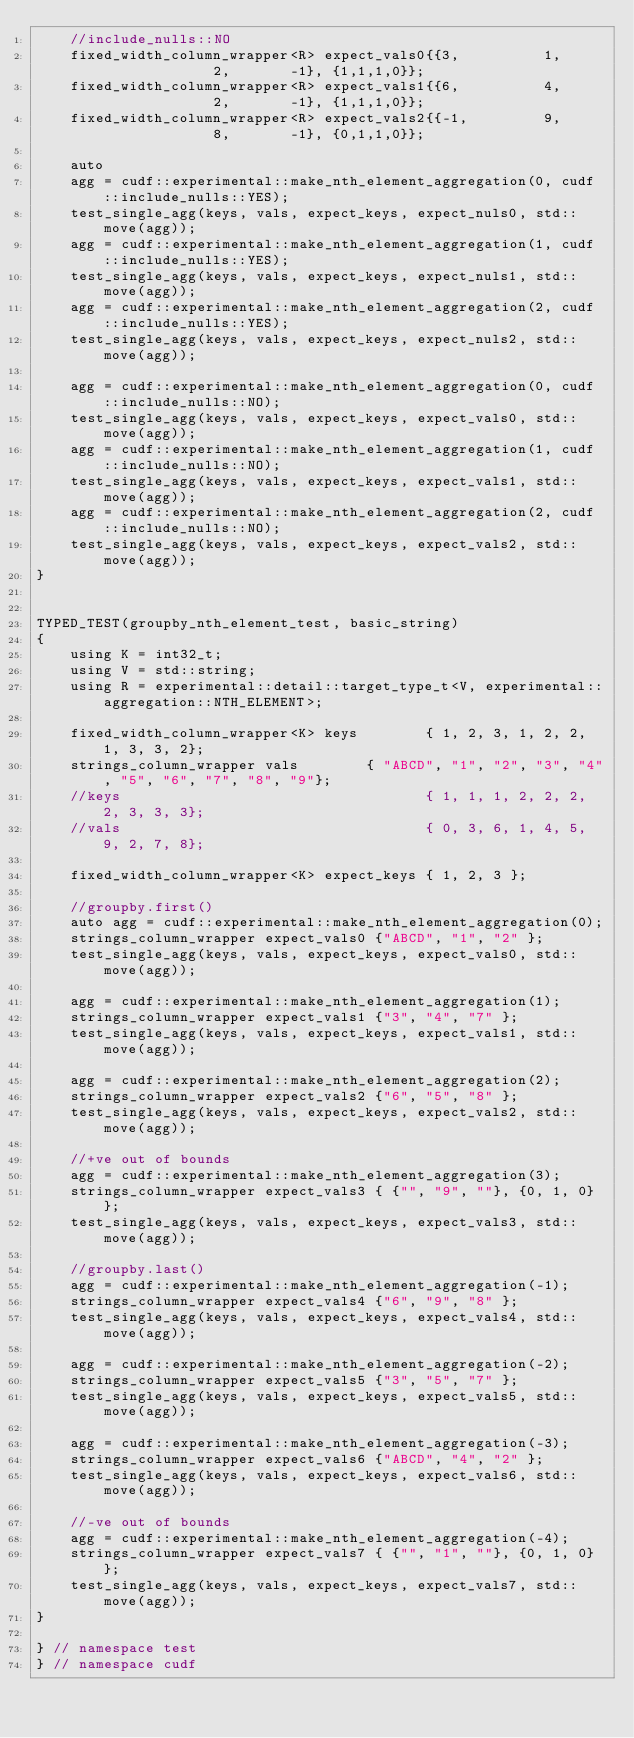Convert code to text. <code><loc_0><loc_0><loc_500><loc_500><_Cuda_>    //include_nulls::NO
    fixed_width_column_wrapper<R> expect_vals0{{3,          1,              2,       -1}, {1,1,1,0}};
    fixed_width_column_wrapper<R> expect_vals1{{6,          4,              2,       -1}, {1,1,1,0}};
    fixed_width_column_wrapper<R> expect_vals2{{-1,         9,              8,       -1}, {0,1,1,0}};

    auto 
    agg = cudf::experimental::make_nth_element_aggregation(0, cudf::include_nulls::YES);
    test_single_agg(keys, vals, expect_keys, expect_nuls0, std::move(agg));
    agg = cudf::experimental::make_nth_element_aggregation(1, cudf::include_nulls::YES);
    test_single_agg(keys, vals, expect_keys, expect_nuls1, std::move(agg));
    agg = cudf::experimental::make_nth_element_aggregation(2, cudf::include_nulls::YES);
    test_single_agg(keys, vals, expect_keys, expect_nuls2, std::move(agg));
    
    agg = cudf::experimental::make_nth_element_aggregation(0, cudf::include_nulls::NO);
    test_single_agg(keys, vals, expect_keys, expect_vals0, std::move(agg));
    agg = cudf::experimental::make_nth_element_aggregation(1, cudf::include_nulls::NO);
    test_single_agg(keys, vals, expect_keys, expect_vals1, std::move(agg));
    agg = cudf::experimental::make_nth_element_aggregation(2, cudf::include_nulls::NO);
    test_single_agg(keys, vals, expect_keys, expect_vals2, std::move(agg));
}


TYPED_TEST(groupby_nth_element_test, basic_string)
{
    using K = int32_t;
    using V = std::string;
    using R = experimental::detail::target_type_t<V, experimental::aggregation::NTH_ELEMENT>;

    fixed_width_column_wrapper<K> keys        { 1, 2, 3, 1, 2, 2, 1, 3, 3, 2};
    strings_column_wrapper vals        { "ABCD", "1", "2", "3", "4", "5", "6", "7", "8", "9"};
    //keys                                    { 1, 1, 1, 2, 2, 2, 2, 3, 3, 3};
    //vals                                    { 0, 3, 6, 1, 4, 5, 9, 2, 7, 8};

    fixed_width_column_wrapper<K> expect_keys { 1, 2, 3 };

    //groupby.first()
    auto agg = cudf::experimental::make_nth_element_aggregation(0);
    strings_column_wrapper expect_vals0 {"ABCD", "1", "2" };
    test_single_agg(keys, vals, expect_keys, expect_vals0, std::move(agg));

    agg = cudf::experimental::make_nth_element_aggregation(1);
    strings_column_wrapper expect_vals1 {"3", "4", "7" };
    test_single_agg(keys, vals, expect_keys, expect_vals1, std::move(agg));

    agg = cudf::experimental::make_nth_element_aggregation(2);
    strings_column_wrapper expect_vals2 {"6", "5", "8" };
    test_single_agg(keys, vals, expect_keys, expect_vals2, std::move(agg));

    //+ve out of bounds
    agg = cudf::experimental::make_nth_element_aggregation(3);
    strings_column_wrapper expect_vals3 { {"", "9", ""}, {0, 1, 0} };
    test_single_agg(keys, vals, expect_keys, expect_vals3, std::move(agg));

    //groupby.last()
    agg = cudf::experimental::make_nth_element_aggregation(-1);
    strings_column_wrapper expect_vals4 {"6", "9", "8" };
    test_single_agg(keys, vals, expect_keys, expect_vals4, std::move(agg));

    agg = cudf::experimental::make_nth_element_aggregation(-2);
    strings_column_wrapper expect_vals5 {"3", "5", "7" };
    test_single_agg(keys, vals, expect_keys, expect_vals5, std::move(agg));

    agg = cudf::experimental::make_nth_element_aggregation(-3);
    strings_column_wrapper expect_vals6 {"ABCD", "4", "2" };
    test_single_agg(keys, vals, expect_keys, expect_vals6, std::move(agg));
    
    //-ve out of bounds
    agg = cudf::experimental::make_nth_element_aggregation(-4);
    strings_column_wrapper expect_vals7 { {"", "1", ""}, {0, 1, 0} };
    test_single_agg(keys, vals, expect_keys, expect_vals7, std::move(agg));
}

} // namespace test
} // namespace cudf
</code> 